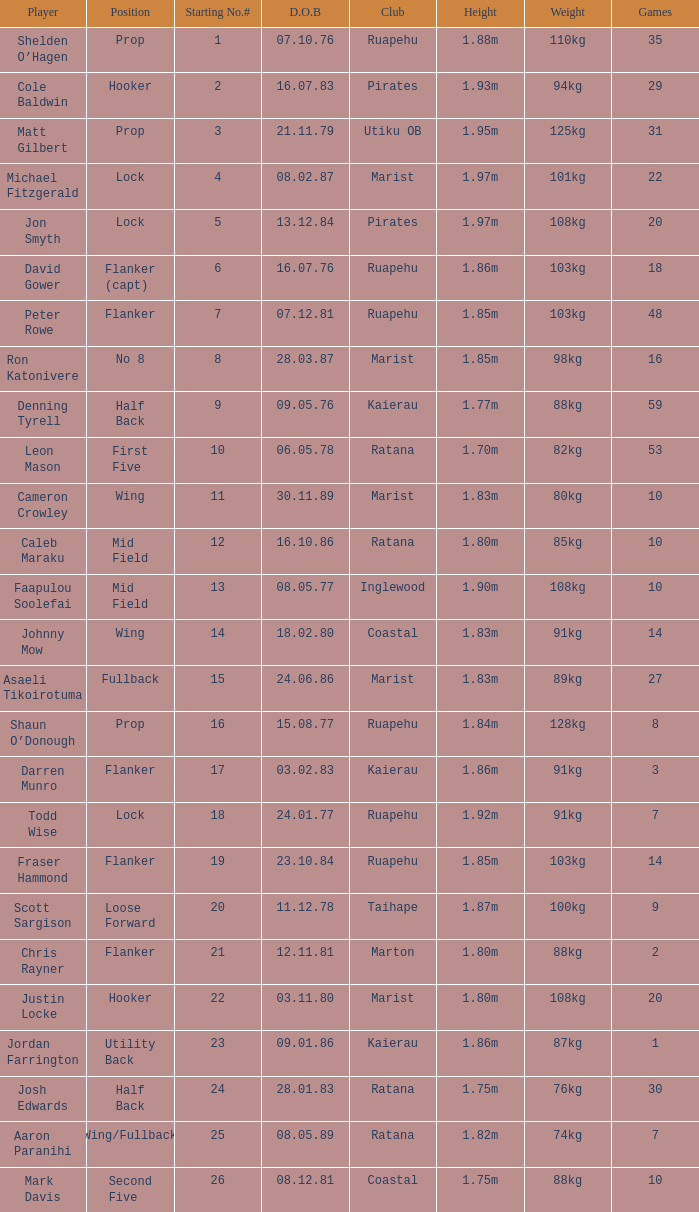What position does the player Todd Wise play in? Lock. 